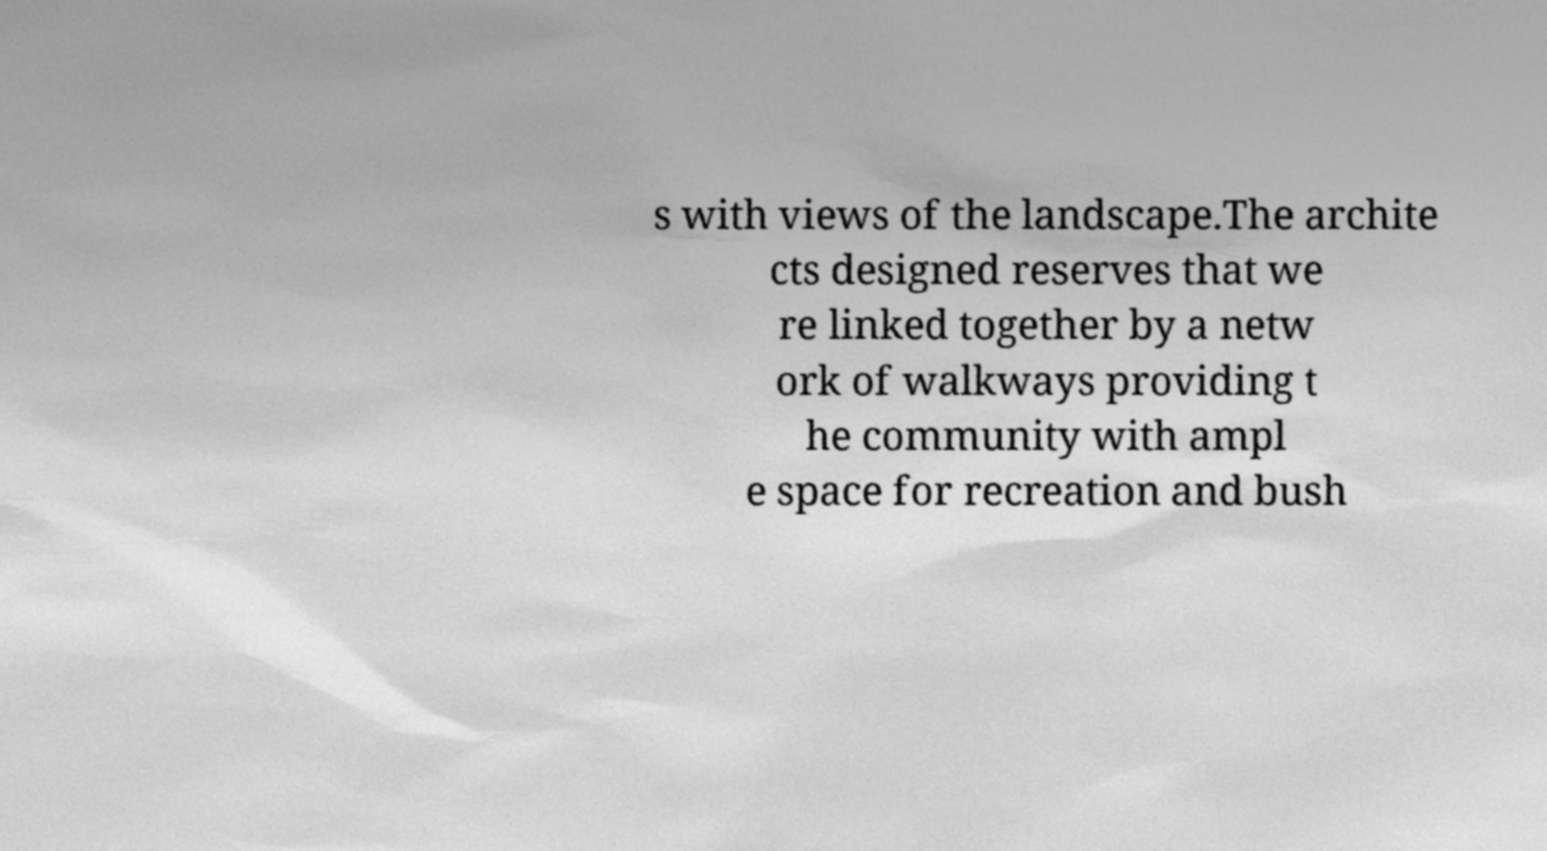There's text embedded in this image that I need extracted. Can you transcribe it verbatim? s with views of the landscape.The archite cts designed reserves that we re linked together by a netw ork of walkways providing t he community with ampl e space for recreation and bush 